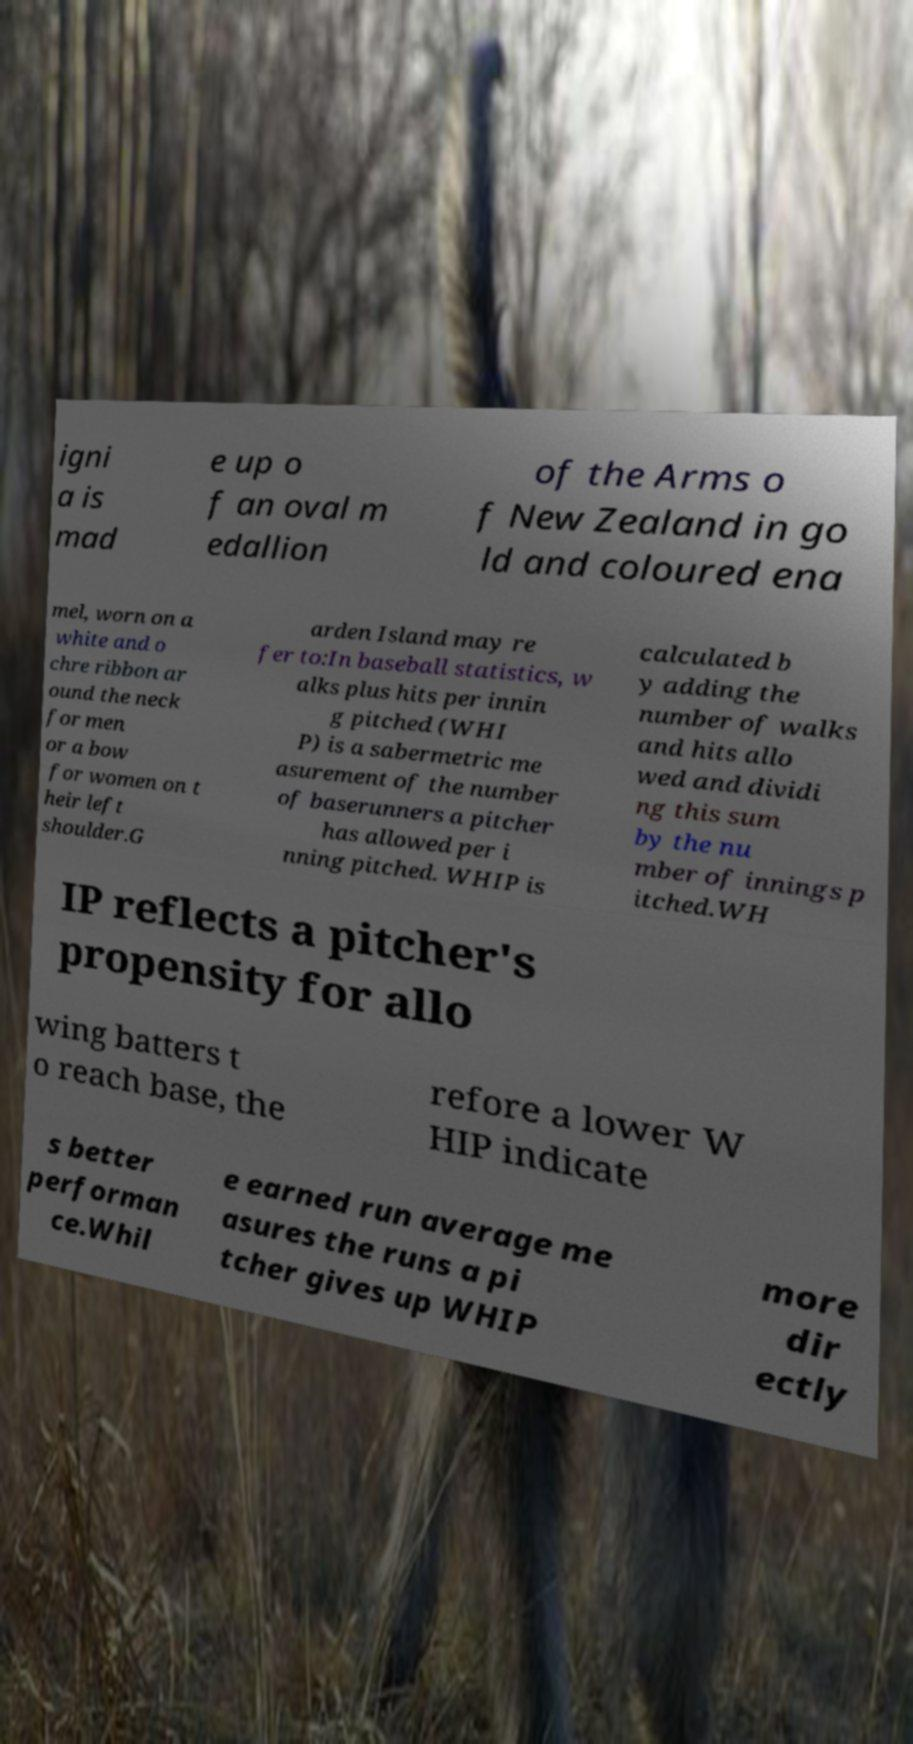What messages or text are displayed in this image? I need them in a readable, typed format. igni a is mad e up o f an oval m edallion of the Arms o f New Zealand in go ld and coloured ena mel, worn on a white and o chre ribbon ar ound the neck for men or a bow for women on t heir left shoulder.G arden Island may re fer to:In baseball statistics, w alks plus hits per innin g pitched (WHI P) is a sabermetric me asurement of the number of baserunners a pitcher has allowed per i nning pitched. WHIP is calculated b y adding the number of walks and hits allo wed and dividi ng this sum by the nu mber of innings p itched.WH IP reflects a pitcher's propensity for allo wing batters t o reach base, the refore a lower W HIP indicate s better performan ce.Whil e earned run average me asures the runs a pi tcher gives up WHIP more dir ectly 